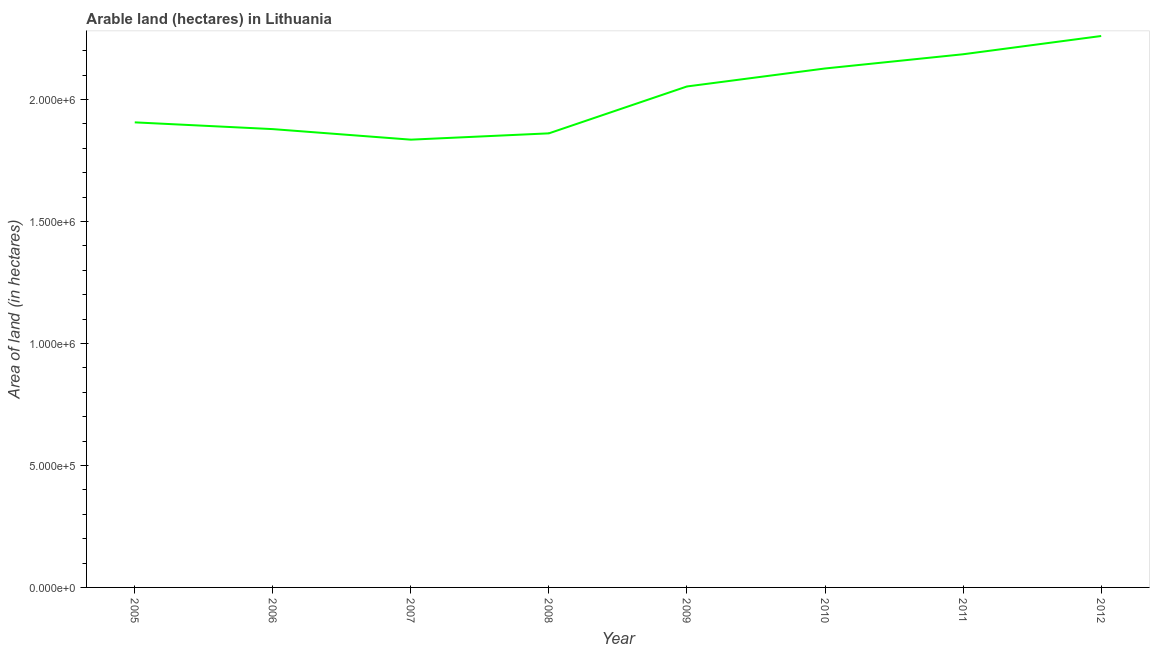What is the area of land in 2010?
Keep it short and to the point. 2.13e+06. Across all years, what is the maximum area of land?
Your answer should be very brief. 2.26e+06. Across all years, what is the minimum area of land?
Keep it short and to the point. 1.84e+06. In which year was the area of land maximum?
Give a very brief answer. 2012. In which year was the area of land minimum?
Keep it short and to the point. 2007. What is the sum of the area of land?
Provide a short and direct response. 1.61e+07. What is the difference between the area of land in 2009 and 2010?
Offer a very short reply. -7.37e+04. What is the average area of land per year?
Keep it short and to the point. 2.01e+06. What is the median area of land?
Offer a terse response. 1.98e+06. In how many years, is the area of land greater than 400000 hectares?
Provide a succinct answer. 8. What is the ratio of the area of land in 2005 to that in 2012?
Keep it short and to the point. 0.84. Is the area of land in 2006 less than that in 2011?
Provide a succinct answer. Yes. What is the difference between the highest and the second highest area of land?
Provide a short and direct response. 7.48e+04. Is the sum of the area of land in 2007 and 2008 greater than the maximum area of land across all years?
Give a very brief answer. Yes. What is the difference between the highest and the lowest area of land?
Provide a short and direct response. 4.25e+05. How many lines are there?
Your answer should be very brief. 1. Are the values on the major ticks of Y-axis written in scientific E-notation?
Give a very brief answer. Yes. Does the graph contain any zero values?
Provide a short and direct response. No. What is the title of the graph?
Your answer should be compact. Arable land (hectares) in Lithuania. What is the label or title of the X-axis?
Make the answer very short. Year. What is the label or title of the Y-axis?
Your answer should be very brief. Area of land (in hectares). What is the Area of land (in hectares) in 2005?
Keep it short and to the point. 1.91e+06. What is the Area of land (in hectares) of 2006?
Make the answer very short. 1.88e+06. What is the Area of land (in hectares) in 2007?
Your answer should be very brief. 1.84e+06. What is the Area of land (in hectares) of 2008?
Provide a succinct answer. 1.86e+06. What is the Area of land (in hectares) of 2009?
Give a very brief answer. 2.05e+06. What is the Area of land (in hectares) in 2010?
Give a very brief answer. 2.13e+06. What is the Area of land (in hectares) of 2011?
Ensure brevity in your answer.  2.19e+06. What is the Area of land (in hectares) in 2012?
Your answer should be compact. 2.26e+06. What is the difference between the Area of land (in hectares) in 2005 and 2006?
Offer a very short reply. 2.77e+04. What is the difference between the Area of land (in hectares) in 2005 and 2007?
Provide a succinct answer. 7.09e+04. What is the difference between the Area of land (in hectares) in 2005 and 2008?
Provide a succinct answer. 4.50e+04. What is the difference between the Area of land (in hectares) in 2005 and 2009?
Ensure brevity in your answer.  -1.47e+05. What is the difference between the Area of land (in hectares) in 2005 and 2010?
Offer a terse response. -2.21e+05. What is the difference between the Area of land (in hectares) in 2005 and 2011?
Provide a succinct answer. -2.79e+05. What is the difference between the Area of land (in hectares) in 2005 and 2012?
Your answer should be very brief. -3.54e+05. What is the difference between the Area of land (in hectares) in 2006 and 2007?
Offer a terse response. 4.32e+04. What is the difference between the Area of land (in hectares) in 2006 and 2008?
Keep it short and to the point. 1.73e+04. What is the difference between the Area of land (in hectares) in 2006 and 2009?
Give a very brief answer. -1.75e+05. What is the difference between the Area of land (in hectares) in 2006 and 2010?
Offer a very short reply. -2.49e+05. What is the difference between the Area of land (in hectares) in 2006 and 2011?
Keep it short and to the point. -3.07e+05. What is the difference between the Area of land (in hectares) in 2006 and 2012?
Your answer should be compact. -3.82e+05. What is the difference between the Area of land (in hectares) in 2007 and 2008?
Keep it short and to the point. -2.59e+04. What is the difference between the Area of land (in hectares) in 2007 and 2009?
Make the answer very short. -2.18e+05. What is the difference between the Area of land (in hectares) in 2007 and 2010?
Ensure brevity in your answer.  -2.92e+05. What is the difference between the Area of land (in hectares) in 2007 and 2011?
Your answer should be compact. -3.50e+05. What is the difference between the Area of land (in hectares) in 2007 and 2012?
Ensure brevity in your answer.  -4.25e+05. What is the difference between the Area of land (in hectares) in 2008 and 2009?
Ensure brevity in your answer.  -1.92e+05. What is the difference between the Area of land (in hectares) in 2008 and 2010?
Keep it short and to the point. -2.66e+05. What is the difference between the Area of land (in hectares) in 2008 and 2011?
Your response must be concise. -3.24e+05. What is the difference between the Area of land (in hectares) in 2008 and 2012?
Make the answer very short. -3.99e+05. What is the difference between the Area of land (in hectares) in 2009 and 2010?
Make the answer very short. -7.37e+04. What is the difference between the Area of land (in hectares) in 2009 and 2011?
Offer a terse response. -1.32e+05. What is the difference between the Area of land (in hectares) in 2009 and 2012?
Your answer should be very brief. -2.07e+05. What is the difference between the Area of land (in hectares) in 2010 and 2011?
Your answer should be very brief. -5.83e+04. What is the difference between the Area of land (in hectares) in 2010 and 2012?
Ensure brevity in your answer.  -1.33e+05. What is the difference between the Area of land (in hectares) in 2011 and 2012?
Offer a terse response. -7.48e+04. What is the ratio of the Area of land (in hectares) in 2005 to that in 2007?
Your answer should be compact. 1.04. What is the ratio of the Area of land (in hectares) in 2005 to that in 2009?
Give a very brief answer. 0.93. What is the ratio of the Area of land (in hectares) in 2005 to that in 2010?
Provide a succinct answer. 0.9. What is the ratio of the Area of land (in hectares) in 2005 to that in 2011?
Offer a terse response. 0.87. What is the ratio of the Area of land (in hectares) in 2005 to that in 2012?
Your answer should be compact. 0.84. What is the ratio of the Area of land (in hectares) in 2006 to that in 2008?
Offer a very short reply. 1.01. What is the ratio of the Area of land (in hectares) in 2006 to that in 2009?
Your response must be concise. 0.92. What is the ratio of the Area of land (in hectares) in 2006 to that in 2010?
Give a very brief answer. 0.88. What is the ratio of the Area of land (in hectares) in 2006 to that in 2011?
Your response must be concise. 0.86. What is the ratio of the Area of land (in hectares) in 2006 to that in 2012?
Ensure brevity in your answer.  0.83. What is the ratio of the Area of land (in hectares) in 2007 to that in 2009?
Your answer should be compact. 0.89. What is the ratio of the Area of land (in hectares) in 2007 to that in 2010?
Offer a terse response. 0.86. What is the ratio of the Area of land (in hectares) in 2007 to that in 2011?
Give a very brief answer. 0.84. What is the ratio of the Area of land (in hectares) in 2007 to that in 2012?
Your response must be concise. 0.81. What is the ratio of the Area of land (in hectares) in 2008 to that in 2009?
Your answer should be compact. 0.91. What is the ratio of the Area of land (in hectares) in 2008 to that in 2010?
Offer a terse response. 0.88. What is the ratio of the Area of land (in hectares) in 2008 to that in 2011?
Your response must be concise. 0.85. What is the ratio of the Area of land (in hectares) in 2008 to that in 2012?
Keep it short and to the point. 0.82. What is the ratio of the Area of land (in hectares) in 2009 to that in 2010?
Ensure brevity in your answer.  0.96. What is the ratio of the Area of land (in hectares) in 2009 to that in 2012?
Make the answer very short. 0.91. What is the ratio of the Area of land (in hectares) in 2010 to that in 2012?
Provide a succinct answer. 0.94. What is the ratio of the Area of land (in hectares) in 2011 to that in 2012?
Your response must be concise. 0.97. 